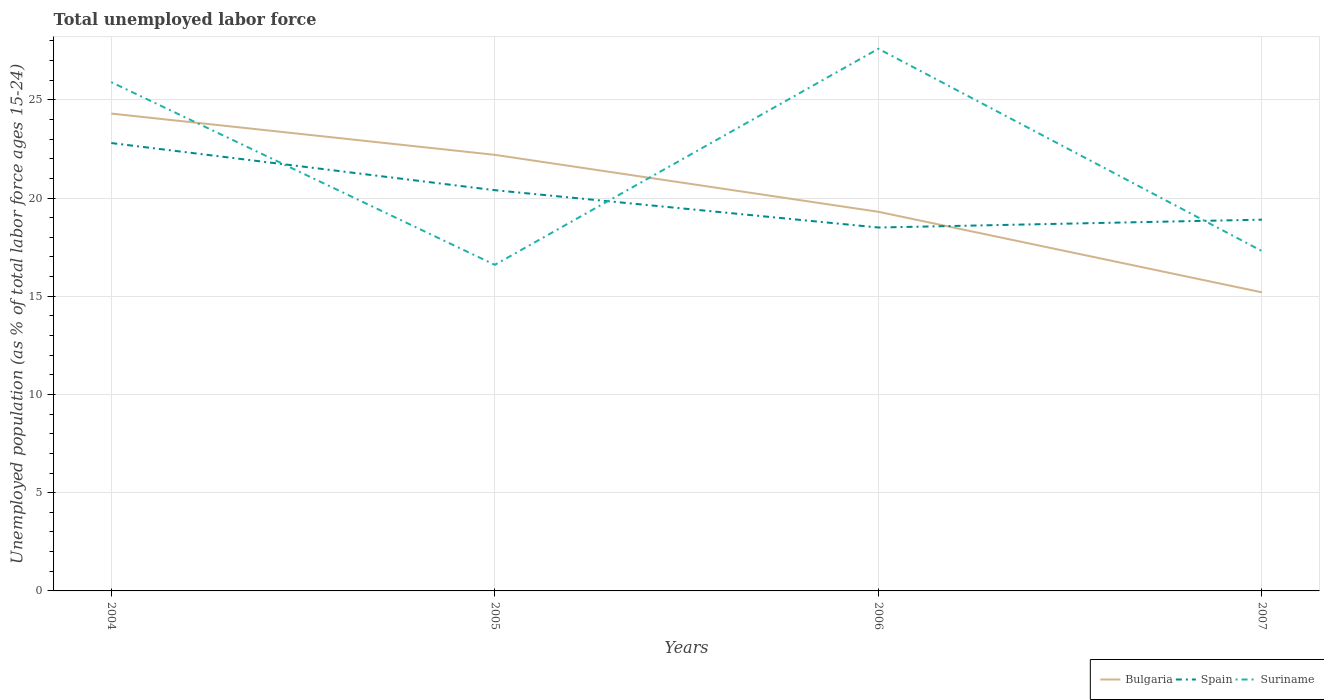How many different coloured lines are there?
Provide a succinct answer. 3. Is the number of lines equal to the number of legend labels?
Your response must be concise. Yes. Across all years, what is the maximum percentage of unemployed population in in Suriname?
Provide a short and direct response. 16.6. In which year was the percentage of unemployed population in in Bulgaria maximum?
Offer a very short reply. 2007. What is the total percentage of unemployed population in in Bulgaria in the graph?
Keep it short and to the point. 7. What is the difference between the highest and the second highest percentage of unemployed population in in Bulgaria?
Your answer should be compact. 9.1. How many lines are there?
Your answer should be very brief. 3. How many years are there in the graph?
Keep it short and to the point. 4. Does the graph contain any zero values?
Your response must be concise. No. What is the title of the graph?
Your answer should be compact. Total unemployed labor force. Does "Georgia" appear as one of the legend labels in the graph?
Offer a terse response. No. What is the label or title of the Y-axis?
Make the answer very short. Unemployed population (as % of total labor force ages 15-24). What is the Unemployed population (as % of total labor force ages 15-24) in Bulgaria in 2004?
Offer a very short reply. 24.3. What is the Unemployed population (as % of total labor force ages 15-24) in Spain in 2004?
Provide a succinct answer. 22.8. What is the Unemployed population (as % of total labor force ages 15-24) in Suriname in 2004?
Provide a short and direct response. 25.9. What is the Unemployed population (as % of total labor force ages 15-24) in Bulgaria in 2005?
Provide a succinct answer. 22.2. What is the Unemployed population (as % of total labor force ages 15-24) in Spain in 2005?
Your answer should be very brief. 20.4. What is the Unemployed population (as % of total labor force ages 15-24) in Suriname in 2005?
Your answer should be very brief. 16.6. What is the Unemployed population (as % of total labor force ages 15-24) in Bulgaria in 2006?
Your answer should be very brief. 19.3. What is the Unemployed population (as % of total labor force ages 15-24) in Suriname in 2006?
Provide a short and direct response. 27.6. What is the Unemployed population (as % of total labor force ages 15-24) of Bulgaria in 2007?
Ensure brevity in your answer.  15.2. What is the Unemployed population (as % of total labor force ages 15-24) of Spain in 2007?
Give a very brief answer. 18.9. What is the Unemployed population (as % of total labor force ages 15-24) in Suriname in 2007?
Keep it short and to the point. 17.3. Across all years, what is the maximum Unemployed population (as % of total labor force ages 15-24) of Bulgaria?
Provide a short and direct response. 24.3. Across all years, what is the maximum Unemployed population (as % of total labor force ages 15-24) of Spain?
Offer a terse response. 22.8. Across all years, what is the maximum Unemployed population (as % of total labor force ages 15-24) of Suriname?
Keep it short and to the point. 27.6. Across all years, what is the minimum Unemployed population (as % of total labor force ages 15-24) of Bulgaria?
Your answer should be very brief. 15.2. Across all years, what is the minimum Unemployed population (as % of total labor force ages 15-24) in Suriname?
Offer a very short reply. 16.6. What is the total Unemployed population (as % of total labor force ages 15-24) in Bulgaria in the graph?
Your answer should be compact. 81. What is the total Unemployed population (as % of total labor force ages 15-24) of Spain in the graph?
Offer a terse response. 80.6. What is the total Unemployed population (as % of total labor force ages 15-24) of Suriname in the graph?
Provide a short and direct response. 87.4. What is the difference between the Unemployed population (as % of total labor force ages 15-24) in Suriname in 2004 and that in 2006?
Ensure brevity in your answer.  -1.7. What is the difference between the Unemployed population (as % of total labor force ages 15-24) in Suriname in 2004 and that in 2007?
Provide a short and direct response. 8.6. What is the difference between the Unemployed population (as % of total labor force ages 15-24) in Bulgaria in 2005 and that in 2006?
Offer a terse response. 2.9. What is the difference between the Unemployed population (as % of total labor force ages 15-24) of Spain in 2005 and that in 2006?
Make the answer very short. 1.9. What is the difference between the Unemployed population (as % of total labor force ages 15-24) in Suriname in 2005 and that in 2006?
Ensure brevity in your answer.  -11. What is the difference between the Unemployed population (as % of total labor force ages 15-24) in Bulgaria in 2005 and that in 2007?
Your answer should be compact. 7. What is the difference between the Unemployed population (as % of total labor force ages 15-24) of Spain in 2006 and that in 2007?
Ensure brevity in your answer.  -0.4. What is the difference between the Unemployed population (as % of total labor force ages 15-24) of Suriname in 2006 and that in 2007?
Offer a terse response. 10.3. What is the difference between the Unemployed population (as % of total labor force ages 15-24) in Bulgaria in 2004 and the Unemployed population (as % of total labor force ages 15-24) in Spain in 2005?
Ensure brevity in your answer.  3.9. What is the difference between the Unemployed population (as % of total labor force ages 15-24) of Bulgaria in 2004 and the Unemployed population (as % of total labor force ages 15-24) of Suriname in 2005?
Offer a terse response. 7.7. What is the difference between the Unemployed population (as % of total labor force ages 15-24) of Spain in 2004 and the Unemployed population (as % of total labor force ages 15-24) of Suriname in 2005?
Your answer should be very brief. 6.2. What is the difference between the Unemployed population (as % of total labor force ages 15-24) of Bulgaria in 2004 and the Unemployed population (as % of total labor force ages 15-24) of Suriname in 2006?
Your answer should be very brief. -3.3. What is the difference between the Unemployed population (as % of total labor force ages 15-24) of Bulgaria in 2004 and the Unemployed population (as % of total labor force ages 15-24) of Suriname in 2007?
Your response must be concise. 7. What is the difference between the Unemployed population (as % of total labor force ages 15-24) of Bulgaria in 2005 and the Unemployed population (as % of total labor force ages 15-24) of Spain in 2006?
Your answer should be very brief. 3.7. What is the difference between the Unemployed population (as % of total labor force ages 15-24) of Bulgaria in 2005 and the Unemployed population (as % of total labor force ages 15-24) of Suriname in 2006?
Your answer should be very brief. -5.4. What is the difference between the Unemployed population (as % of total labor force ages 15-24) of Spain in 2005 and the Unemployed population (as % of total labor force ages 15-24) of Suriname in 2006?
Give a very brief answer. -7.2. What is the difference between the Unemployed population (as % of total labor force ages 15-24) of Spain in 2005 and the Unemployed population (as % of total labor force ages 15-24) of Suriname in 2007?
Offer a terse response. 3.1. What is the difference between the Unemployed population (as % of total labor force ages 15-24) of Bulgaria in 2006 and the Unemployed population (as % of total labor force ages 15-24) of Suriname in 2007?
Make the answer very short. 2. What is the difference between the Unemployed population (as % of total labor force ages 15-24) of Spain in 2006 and the Unemployed population (as % of total labor force ages 15-24) of Suriname in 2007?
Offer a terse response. 1.2. What is the average Unemployed population (as % of total labor force ages 15-24) of Bulgaria per year?
Provide a succinct answer. 20.25. What is the average Unemployed population (as % of total labor force ages 15-24) of Spain per year?
Your response must be concise. 20.15. What is the average Unemployed population (as % of total labor force ages 15-24) in Suriname per year?
Ensure brevity in your answer.  21.85. In the year 2004, what is the difference between the Unemployed population (as % of total labor force ages 15-24) of Bulgaria and Unemployed population (as % of total labor force ages 15-24) of Spain?
Ensure brevity in your answer.  1.5. In the year 2005, what is the difference between the Unemployed population (as % of total labor force ages 15-24) of Bulgaria and Unemployed population (as % of total labor force ages 15-24) of Suriname?
Your response must be concise. 5.6. In the year 2005, what is the difference between the Unemployed population (as % of total labor force ages 15-24) of Spain and Unemployed population (as % of total labor force ages 15-24) of Suriname?
Your answer should be compact. 3.8. In the year 2006, what is the difference between the Unemployed population (as % of total labor force ages 15-24) of Bulgaria and Unemployed population (as % of total labor force ages 15-24) of Suriname?
Your response must be concise. -8.3. In the year 2006, what is the difference between the Unemployed population (as % of total labor force ages 15-24) of Spain and Unemployed population (as % of total labor force ages 15-24) of Suriname?
Give a very brief answer. -9.1. In the year 2007, what is the difference between the Unemployed population (as % of total labor force ages 15-24) of Bulgaria and Unemployed population (as % of total labor force ages 15-24) of Spain?
Offer a very short reply. -3.7. What is the ratio of the Unemployed population (as % of total labor force ages 15-24) in Bulgaria in 2004 to that in 2005?
Provide a short and direct response. 1.09. What is the ratio of the Unemployed population (as % of total labor force ages 15-24) of Spain in 2004 to that in 2005?
Offer a very short reply. 1.12. What is the ratio of the Unemployed population (as % of total labor force ages 15-24) in Suriname in 2004 to that in 2005?
Provide a succinct answer. 1.56. What is the ratio of the Unemployed population (as % of total labor force ages 15-24) in Bulgaria in 2004 to that in 2006?
Your answer should be compact. 1.26. What is the ratio of the Unemployed population (as % of total labor force ages 15-24) in Spain in 2004 to that in 2006?
Provide a short and direct response. 1.23. What is the ratio of the Unemployed population (as % of total labor force ages 15-24) of Suriname in 2004 to that in 2006?
Your response must be concise. 0.94. What is the ratio of the Unemployed population (as % of total labor force ages 15-24) of Bulgaria in 2004 to that in 2007?
Give a very brief answer. 1.6. What is the ratio of the Unemployed population (as % of total labor force ages 15-24) of Spain in 2004 to that in 2007?
Ensure brevity in your answer.  1.21. What is the ratio of the Unemployed population (as % of total labor force ages 15-24) of Suriname in 2004 to that in 2007?
Your response must be concise. 1.5. What is the ratio of the Unemployed population (as % of total labor force ages 15-24) of Bulgaria in 2005 to that in 2006?
Make the answer very short. 1.15. What is the ratio of the Unemployed population (as % of total labor force ages 15-24) of Spain in 2005 to that in 2006?
Keep it short and to the point. 1.1. What is the ratio of the Unemployed population (as % of total labor force ages 15-24) of Suriname in 2005 to that in 2006?
Ensure brevity in your answer.  0.6. What is the ratio of the Unemployed population (as % of total labor force ages 15-24) in Bulgaria in 2005 to that in 2007?
Ensure brevity in your answer.  1.46. What is the ratio of the Unemployed population (as % of total labor force ages 15-24) in Spain in 2005 to that in 2007?
Your response must be concise. 1.08. What is the ratio of the Unemployed population (as % of total labor force ages 15-24) in Suriname in 2005 to that in 2007?
Your answer should be very brief. 0.96. What is the ratio of the Unemployed population (as % of total labor force ages 15-24) of Bulgaria in 2006 to that in 2007?
Offer a terse response. 1.27. What is the ratio of the Unemployed population (as % of total labor force ages 15-24) in Spain in 2006 to that in 2007?
Make the answer very short. 0.98. What is the ratio of the Unemployed population (as % of total labor force ages 15-24) in Suriname in 2006 to that in 2007?
Your answer should be very brief. 1.6. What is the difference between the highest and the second highest Unemployed population (as % of total labor force ages 15-24) in Bulgaria?
Your answer should be compact. 2.1. What is the difference between the highest and the lowest Unemployed population (as % of total labor force ages 15-24) in Bulgaria?
Make the answer very short. 9.1. 